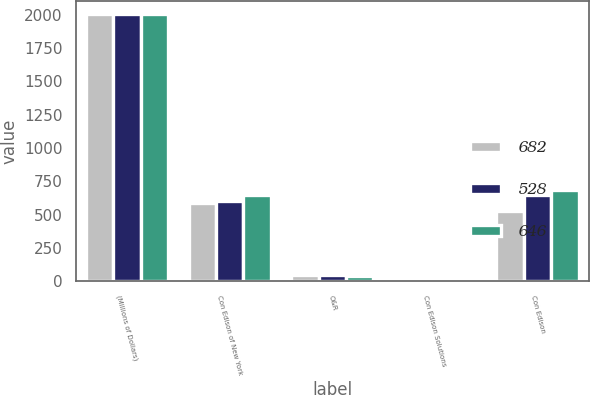<chart> <loc_0><loc_0><loc_500><loc_500><stacked_bar_chart><ecel><fcel>(Millions of Dollars)<fcel>Con Edison of New York<fcel>O&R<fcel>Con Edison Solutions<fcel>Con Edison<nl><fcel>682<fcel>2003<fcel>591<fcel>45<fcel>19<fcel>528<nl><fcel>528<fcel>2002<fcel>605<fcel>45<fcel>22<fcel>646<nl><fcel>646<fcel>2001<fcel>649<fcel>40<fcel>2<fcel>682<nl></chart> 